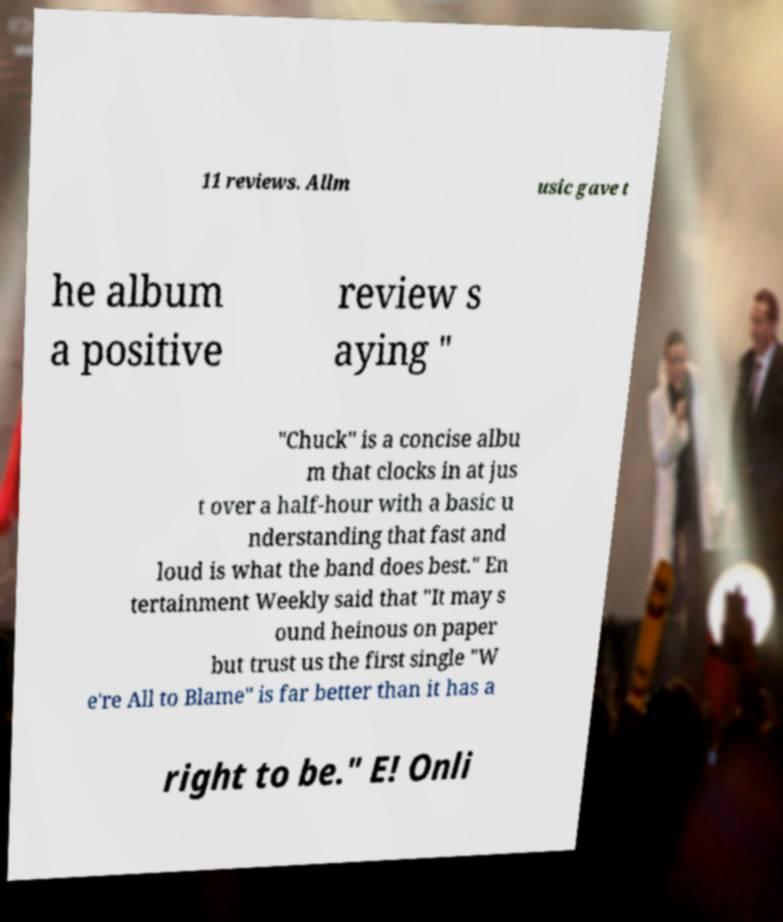Can you read and provide the text displayed in the image?This photo seems to have some interesting text. Can you extract and type it out for me? 11 reviews. Allm usic gave t he album a positive review s aying " "Chuck" is a concise albu m that clocks in at jus t over a half-hour with a basic u nderstanding that fast and loud is what the band does best." En tertainment Weekly said that "It may s ound heinous on paper but trust us the first single "W e're All to Blame" is far better than it has a right to be." E! Onli 